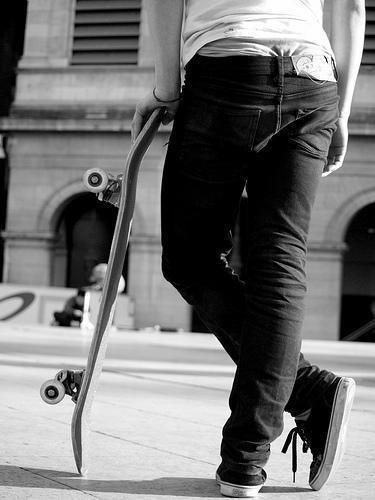How many people are shown in this photo?
Give a very brief answer. 1. 